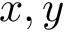<formula> <loc_0><loc_0><loc_500><loc_500>x , y</formula> 